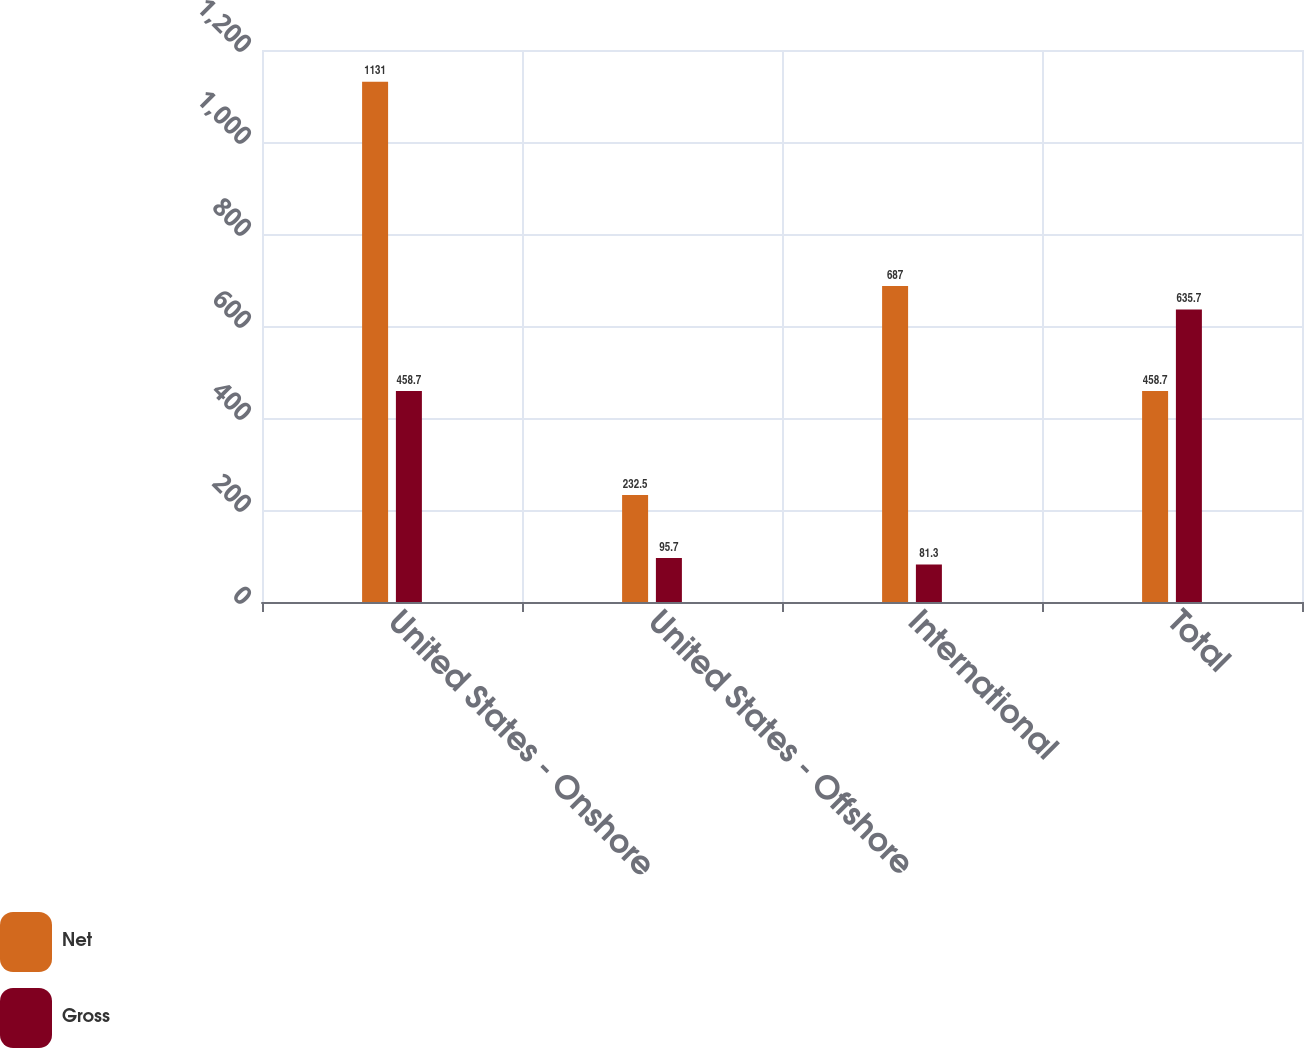Convert chart. <chart><loc_0><loc_0><loc_500><loc_500><stacked_bar_chart><ecel><fcel>United States - Onshore<fcel>United States - Offshore<fcel>International<fcel>Total<nl><fcel>Net<fcel>1131<fcel>232.5<fcel>687<fcel>458.7<nl><fcel>Gross<fcel>458.7<fcel>95.7<fcel>81.3<fcel>635.7<nl></chart> 